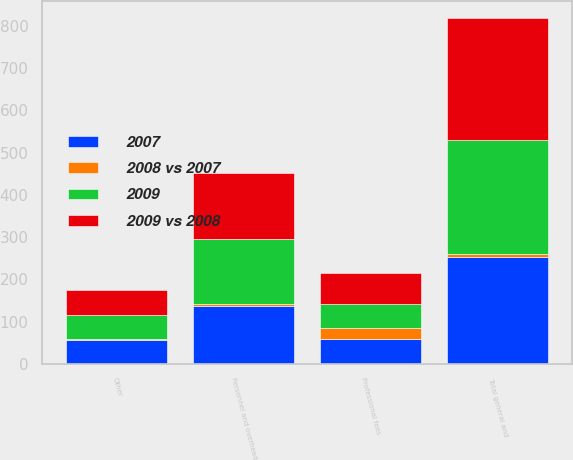Convert chart to OTSL. <chart><loc_0><loc_0><loc_500><loc_500><stacked_bar_chart><ecel><fcel>Personnel and overhead<fcel>Professional fees<fcel>Other<fcel>Total general and<nl><fcel>2009 vs 2008<fcel>158<fcel>74<fcel>58<fcel>290<nl><fcel>2009<fcel>154<fcel>58<fcel>57<fcel>269<nl><fcel>2007<fcel>138<fcel>58<fcel>56<fcel>252<nl><fcel>2008 vs 2007<fcel>3<fcel>26<fcel>3<fcel>8<nl></chart> 